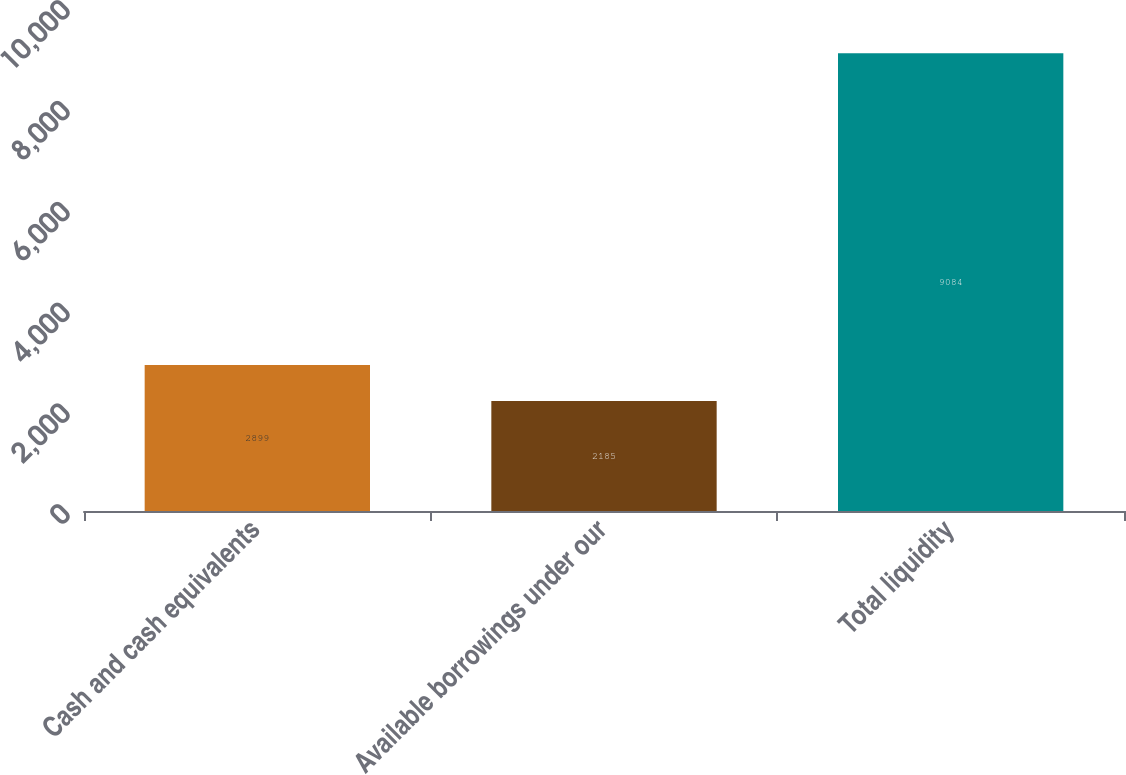Convert chart. <chart><loc_0><loc_0><loc_500><loc_500><bar_chart><fcel>Cash and cash equivalents<fcel>Available borrowings under our<fcel>Total liquidity<nl><fcel>2899<fcel>2185<fcel>9084<nl></chart> 